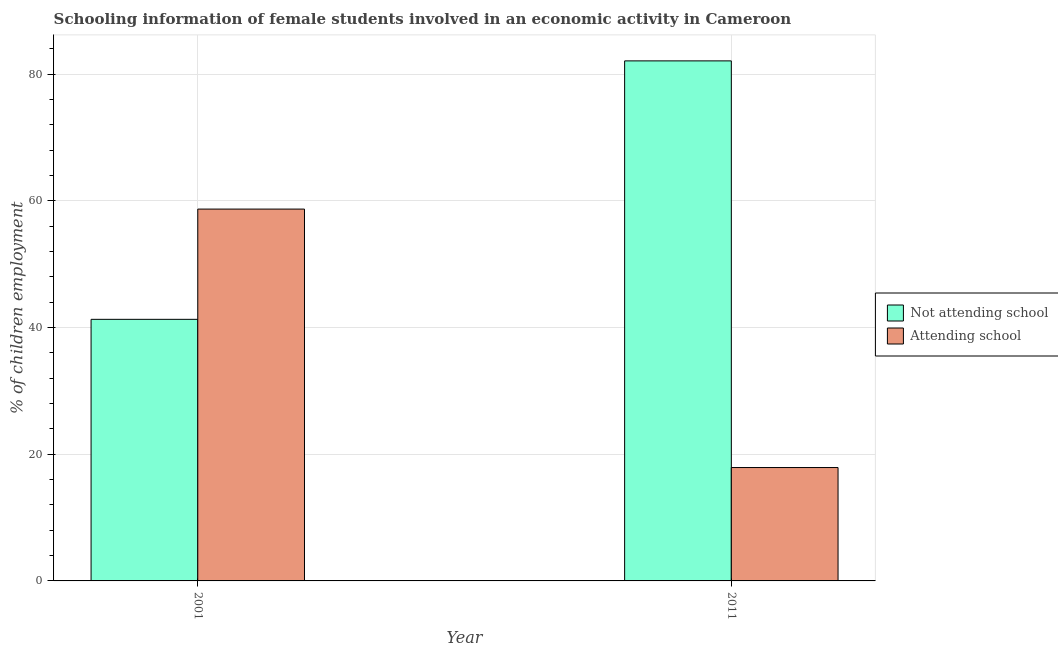Are the number of bars per tick equal to the number of legend labels?
Offer a terse response. Yes. How many bars are there on the 2nd tick from the left?
Offer a very short reply. 2. How many bars are there on the 2nd tick from the right?
Provide a succinct answer. 2. In how many cases, is the number of bars for a given year not equal to the number of legend labels?
Your response must be concise. 0. What is the percentage of employed females who are not attending school in 2011?
Ensure brevity in your answer.  82.1. Across all years, what is the maximum percentage of employed females who are not attending school?
Ensure brevity in your answer.  82.1. Across all years, what is the minimum percentage of employed females who are not attending school?
Provide a succinct answer. 41.3. In which year was the percentage of employed females who are attending school maximum?
Your answer should be very brief. 2001. In which year was the percentage of employed females who are not attending school minimum?
Offer a very short reply. 2001. What is the total percentage of employed females who are attending school in the graph?
Provide a succinct answer. 76.6. What is the difference between the percentage of employed females who are attending school in 2001 and that in 2011?
Make the answer very short. 40.8. What is the difference between the percentage of employed females who are attending school in 2011 and the percentage of employed females who are not attending school in 2001?
Ensure brevity in your answer.  -40.8. What is the average percentage of employed females who are not attending school per year?
Offer a terse response. 61.7. In how many years, is the percentage of employed females who are attending school greater than 64 %?
Provide a short and direct response. 0. What is the ratio of the percentage of employed females who are not attending school in 2001 to that in 2011?
Provide a succinct answer. 0.5. What does the 1st bar from the left in 2001 represents?
Your response must be concise. Not attending school. What does the 1st bar from the right in 2011 represents?
Offer a very short reply. Attending school. Are all the bars in the graph horizontal?
Your answer should be very brief. No. How many years are there in the graph?
Offer a terse response. 2. Does the graph contain grids?
Ensure brevity in your answer.  Yes. Where does the legend appear in the graph?
Offer a very short reply. Center right. How are the legend labels stacked?
Make the answer very short. Vertical. What is the title of the graph?
Give a very brief answer. Schooling information of female students involved in an economic activity in Cameroon. What is the label or title of the X-axis?
Ensure brevity in your answer.  Year. What is the label or title of the Y-axis?
Make the answer very short. % of children employment. What is the % of children employment of Not attending school in 2001?
Your response must be concise. 41.3. What is the % of children employment in Attending school in 2001?
Offer a very short reply. 58.7. What is the % of children employment in Not attending school in 2011?
Keep it short and to the point. 82.1. Across all years, what is the maximum % of children employment in Not attending school?
Your response must be concise. 82.1. Across all years, what is the maximum % of children employment in Attending school?
Give a very brief answer. 58.7. Across all years, what is the minimum % of children employment of Not attending school?
Provide a succinct answer. 41.3. Across all years, what is the minimum % of children employment in Attending school?
Provide a short and direct response. 17.9. What is the total % of children employment of Not attending school in the graph?
Your response must be concise. 123.4. What is the total % of children employment of Attending school in the graph?
Make the answer very short. 76.6. What is the difference between the % of children employment of Not attending school in 2001 and that in 2011?
Your response must be concise. -40.8. What is the difference between the % of children employment of Attending school in 2001 and that in 2011?
Provide a succinct answer. 40.8. What is the difference between the % of children employment in Not attending school in 2001 and the % of children employment in Attending school in 2011?
Ensure brevity in your answer.  23.4. What is the average % of children employment of Not attending school per year?
Offer a very short reply. 61.7. What is the average % of children employment in Attending school per year?
Provide a short and direct response. 38.3. In the year 2001, what is the difference between the % of children employment of Not attending school and % of children employment of Attending school?
Your answer should be compact. -17.41. In the year 2011, what is the difference between the % of children employment in Not attending school and % of children employment in Attending school?
Your answer should be compact. 64.2. What is the ratio of the % of children employment in Not attending school in 2001 to that in 2011?
Keep it short and to the point. 0.5. What is the ratio of the % of children employment in Attending school in 2001 to that in 2011?
Offer a terse response. 3.28. What is the difference between the highest and the second highest % of children employment in Not attending school?
Keep it short and to the point. 40.8. What is the difference between the highest and the second highest % of children employment in Attending school?
Ensure brevity in your answer.  40.8. What is the difference between the highest and the lowest % of children employment in Not attending school?
Your response must be concise. 40.8. What is the difference between the highest and the lowest % of children employment in Attending school?
Keep it short and to the point. 40.8. 